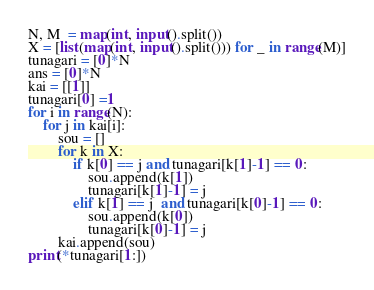Convert code to text. <code><loc_0><loc_0><loc_500><loc_500><_Python_>N, M  = map(int, input().split())
X = [list(map(int, input().split())) for _ in range(M)]
tunagari = [0]*N
ans = [0]*N
kai = [[1]]
tunagari[0] =1
for i in range(N):
    for j in kai[i]:
        sou = []
        for k in X:
            if k[0] == j and tunagari[k[1]-1] == 0:
                sou.append(k[1])
                tunagari[k[1]-1] = j
            elif k[1] == j  and tunagari[k[0]-1] == 0:
                sou.append(k[0])
                tunagari[k[0]-1] = j
        kai.append(sou)
print(*tunagari[1:])</code> 